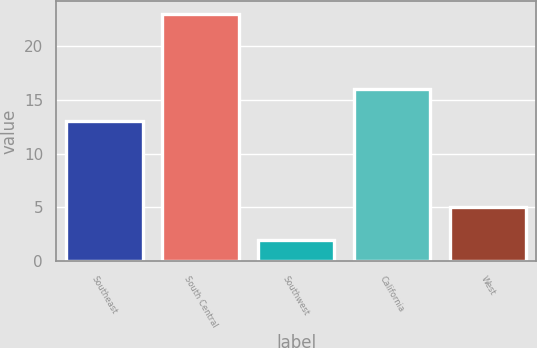Convert chart. <chart><loc_0><loc_0><loc_500><loc_500><bar_chart><fcel>Southeast<fcel>South Central<fcel>Southwest<fcel>California<fcel>West<nl><fcel>13<fcel>23<fcel>2<fcel>16<fcel>5<nl></chart> 